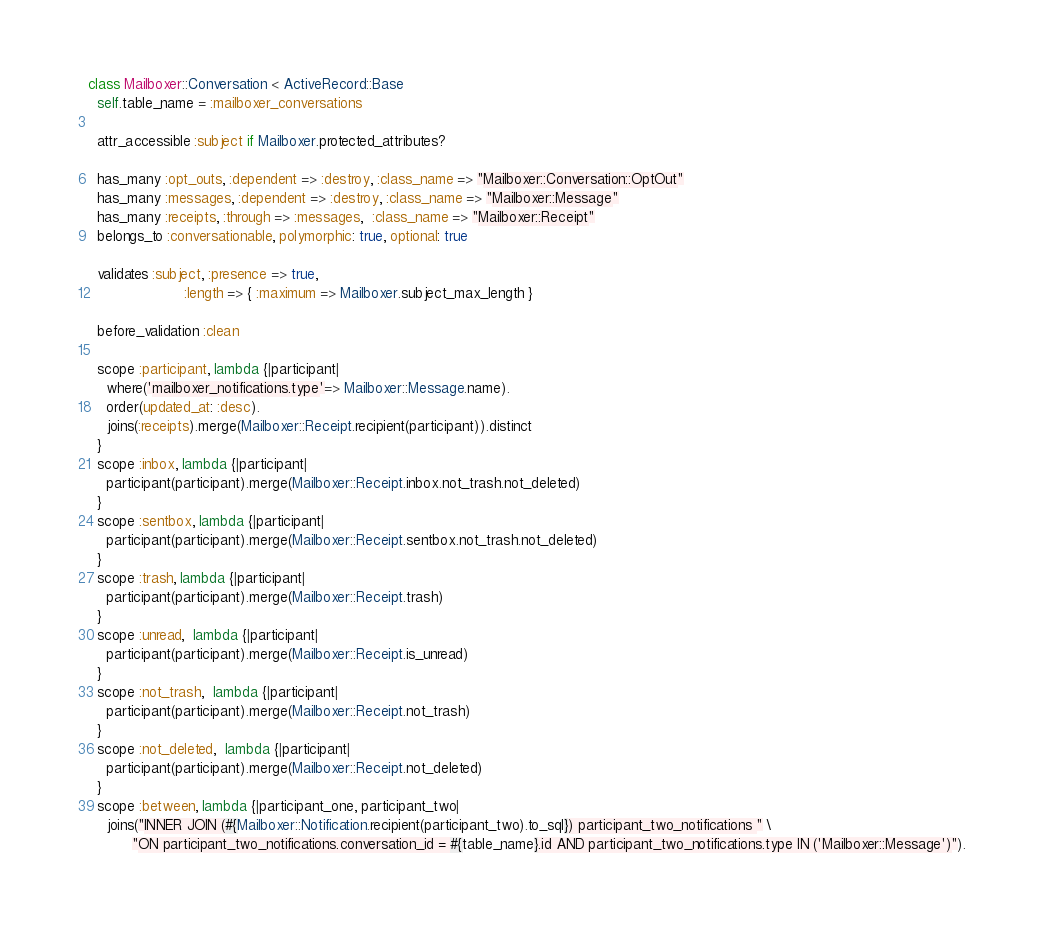Convert code to text. <code><loc_0><loc_0><loc_500><loc_500><_Ruby_>class Mailboxer::Conversation < ActiveRecord::Base
  self.table_name = :mailboxer_conversations

  attr_accessible :subject if Mailboxer.protected_attributes?

  has_many :opt_outs, :dependent => :destroy, :class_name => "Mailboxer::Conversation::OptOut"
  has_many :messages, :dependent => :destroy, :class_name => "Mailboxer::Message"
  has_many :receipts, :through => :messages,  :class_name => "Mailboxer::Receipt"
  belongs_to :conversationable, polymorphic: true, optional: true

  validates :subject, :presence => true,
                      :length => { :maximum => Mailboxer.subject_max_length }

  before_validation :clean

  scope :participant, lambda {|participant|
    where('mailboxer_notifications.type'=> Mailboxer::Message.name).
    order(updated_at: :desc).
    joins(:receipts).merge(Mailboxer::Receipt.recipient(participant)).distinct
  }
  scope :inbox, lambda {|participant|
    participant(participant).merge(Mailboxer::Receipt.inbox.not_trash.not_deleted)
  }
  scope :sentbox, lambda {|participant|
    participant(participant).merge(Mailboxer::Receipt.sentbox.not_trash.not_deleted)
  }
  scope :trash, lambda {|participant|
    participant(participant).merge(Mailboxer::Receipt.trash)
  }
  scope :unread,  lambda {|participant|
    participant(participant).merge(Mailboxer::Receipt.is_unread)
  }
  scope :not_trash,  lambda {|participant|
    participant(participant).merge(Mailboxer::Receipt.not_trash)
  }
  scope :not_deleted,  lambda {|participant|
    participant(participant).merge(Mailboxer::Receipt.not_deleted)
  }
  scope :between, lambda {|participant_one, participant_two|
    joins("INNER JOIN (#{Mailboxer::Notification.recipient(participant_two).to_sql}) participant_two_notifications " \
          "ON participant_two_notifications.conversation_id = #{table_name}.id AND participant_two_notifications.type IN ('Mailboxer::Message')").</code> 